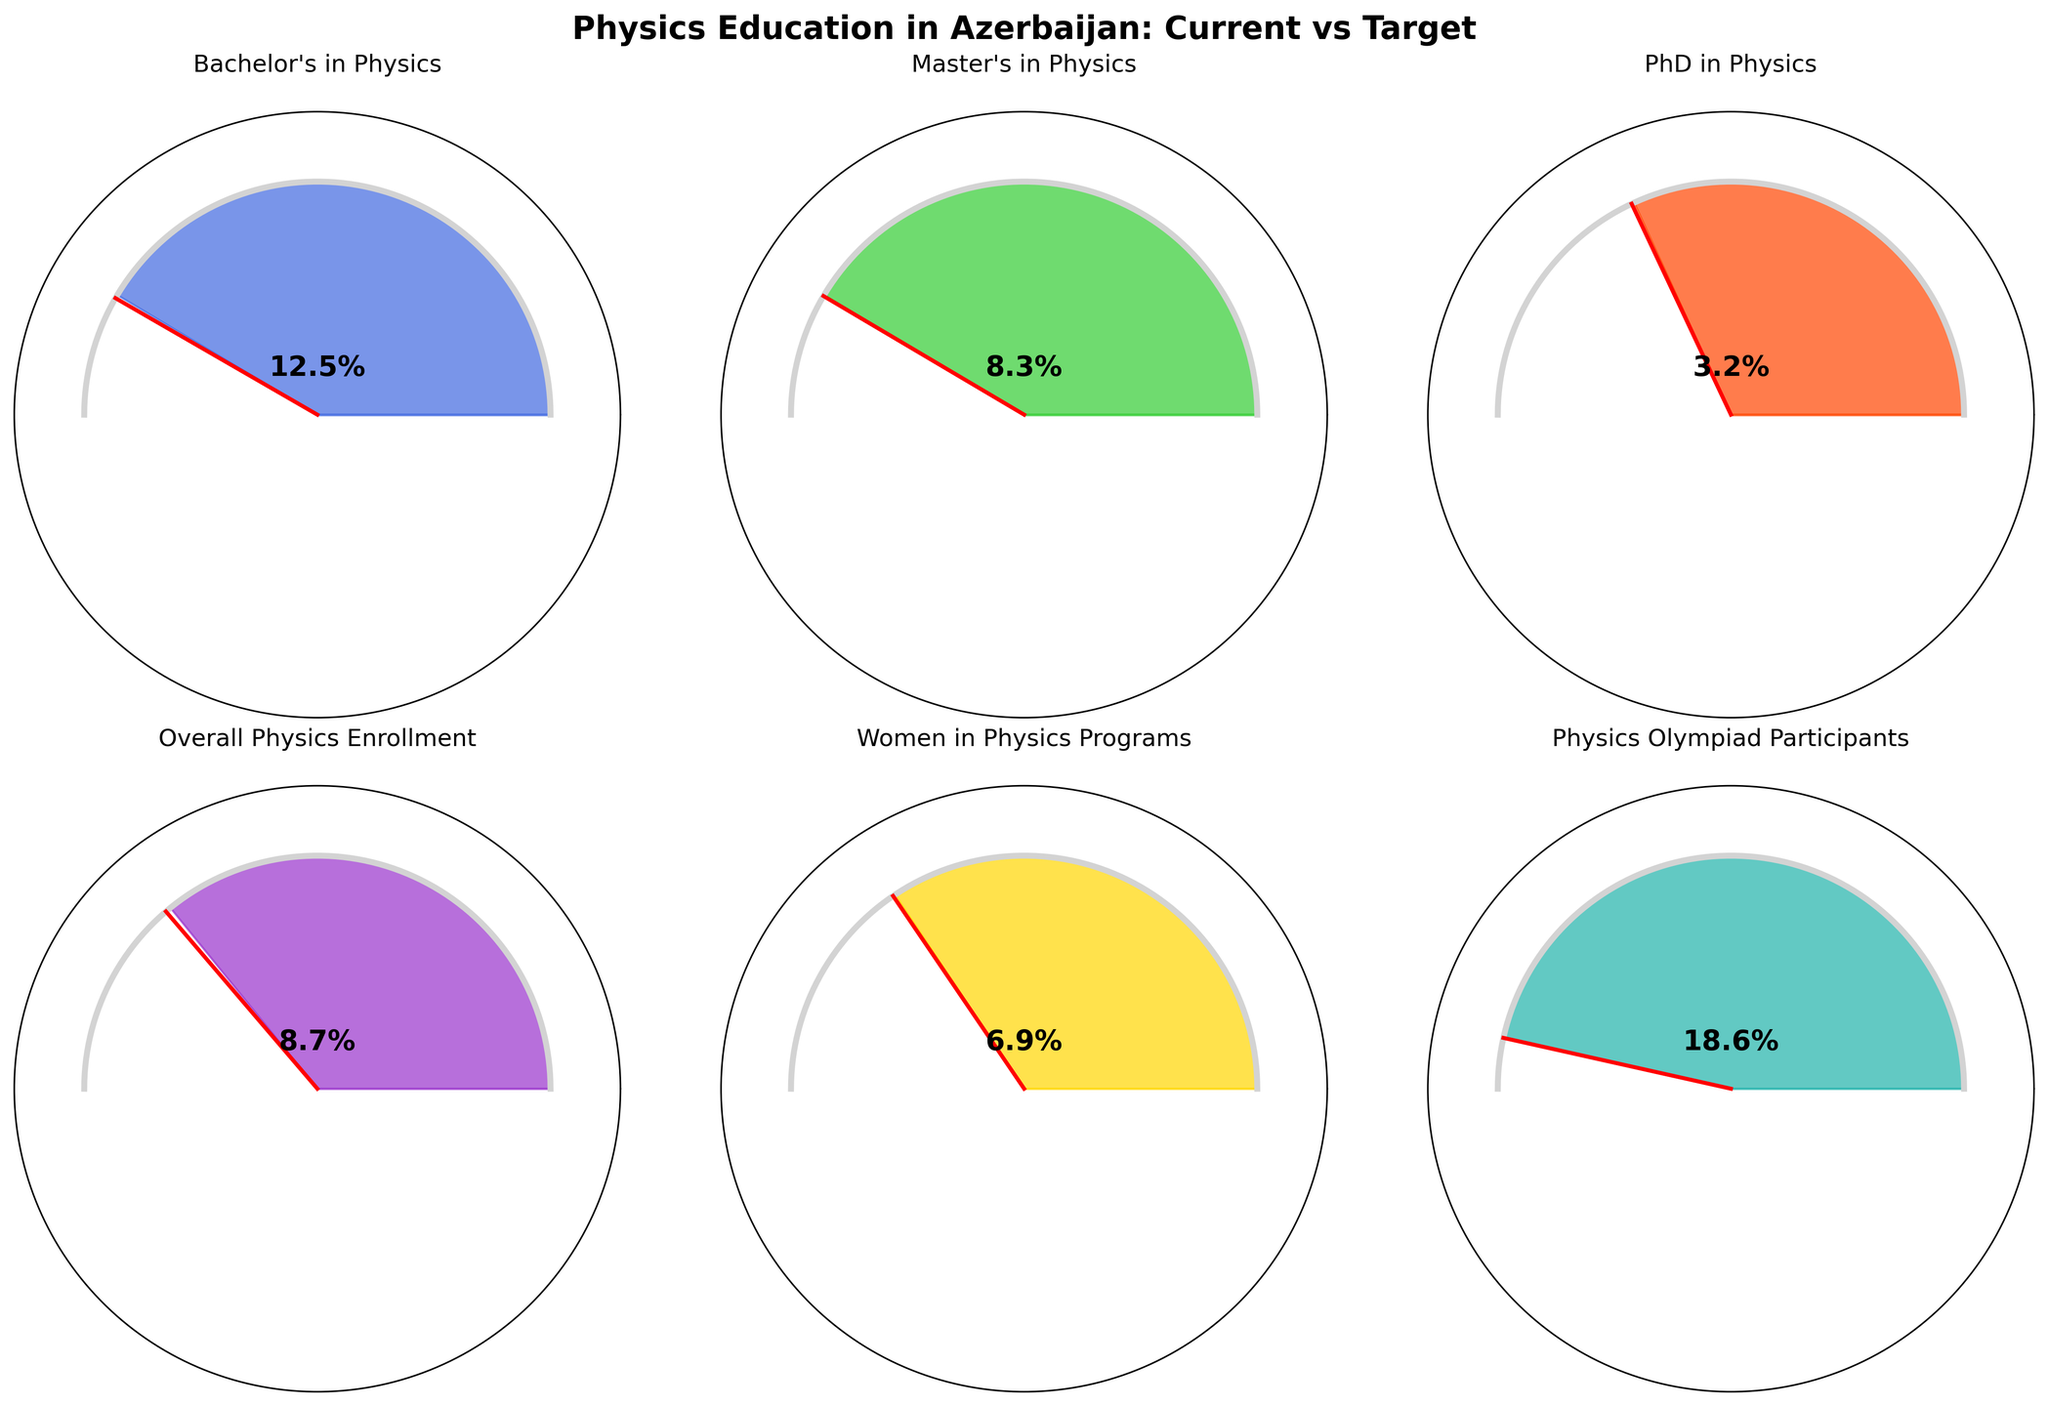What's the overall title of the figure? The title is located at the top of the figure and describes the general subject matter it represents. By looking at the top center of the figure, the title "Physics Education in Azerbaijan: Current vs Target" can be read.
Answer: Physics Education in Azerbaijan: Current vs Target Which category has the highest current value in the figure? By examining the individual gauges presented in the figure, the category "Physics Olympiad Participants" shows the largest current value of 18.6%.
Answer: Physics Olympiad Participants What is the difference between the target and current percentage for PhD in Physics? According to the data on the gauge for "PhD in Physics," the target is 5% and the current value is 3.2%. The difference can be calculated as 5% - 3.2% = 1.8%.
Answer: 1.8% Which category shows the smallest gap between the current value and the target? By scanning the gauges, we observe that the smallest gap between current value and target is in the gauge labeled "Physics Olympiad Participants," which has a gap of 1.4% (20% - 18.6%).
Answer: Physics Olympiad Participants Are more women in physics programs or students pursuing Bachelor's in Physics? The gauges for both "Women in Physics Programs" and "Bachelor's in Physics" can be compared. "Bachelor's in Physics" shows 12.5%, while "Women in Physics Programs" shows 6.9%. Therefore, more students are pursuing Bachelor's in Physics.
Answer: Bachelor's in Physics What's the total target percentage for all categories? To find the total target percentage for all categories, sum the targets: 15% + 10% + 5% + 12% + 10% + 20% = 72%.
Answer: 72% Which category is closest to achieving its target? By comparing the normalized values of each category (current value divided by target), "Physics Olympiad Participants" has the highest normalized value (18.6%/20% = 0.93), indicating it is closest to achieving its target.
Answer: Physics Olympiad Participants What is the average of the current values of all categories? To calculate the average of current values, sum them and then divide by the number of categories: (12.5% + 8.3% + 3.2% + 8.7% + 6.9% + 18.6%) / 6 = 9.7%.
Answer: 9.7% Does any category reach both its current and target values? Upon examining the gauges, it is evident that no category's current value meets or exceeds its respective target value. Each gauge's needle is positioned below the target mark.
Answer: No Which category needs the most improvement to meet its target? By identifying the largest gap between current value and target, "Overall Physics Enrollment" has the largest gap (12% - 8.7% = 3.3%). This category needs the most improvement.
Answer: Overall Physics Enrollment 